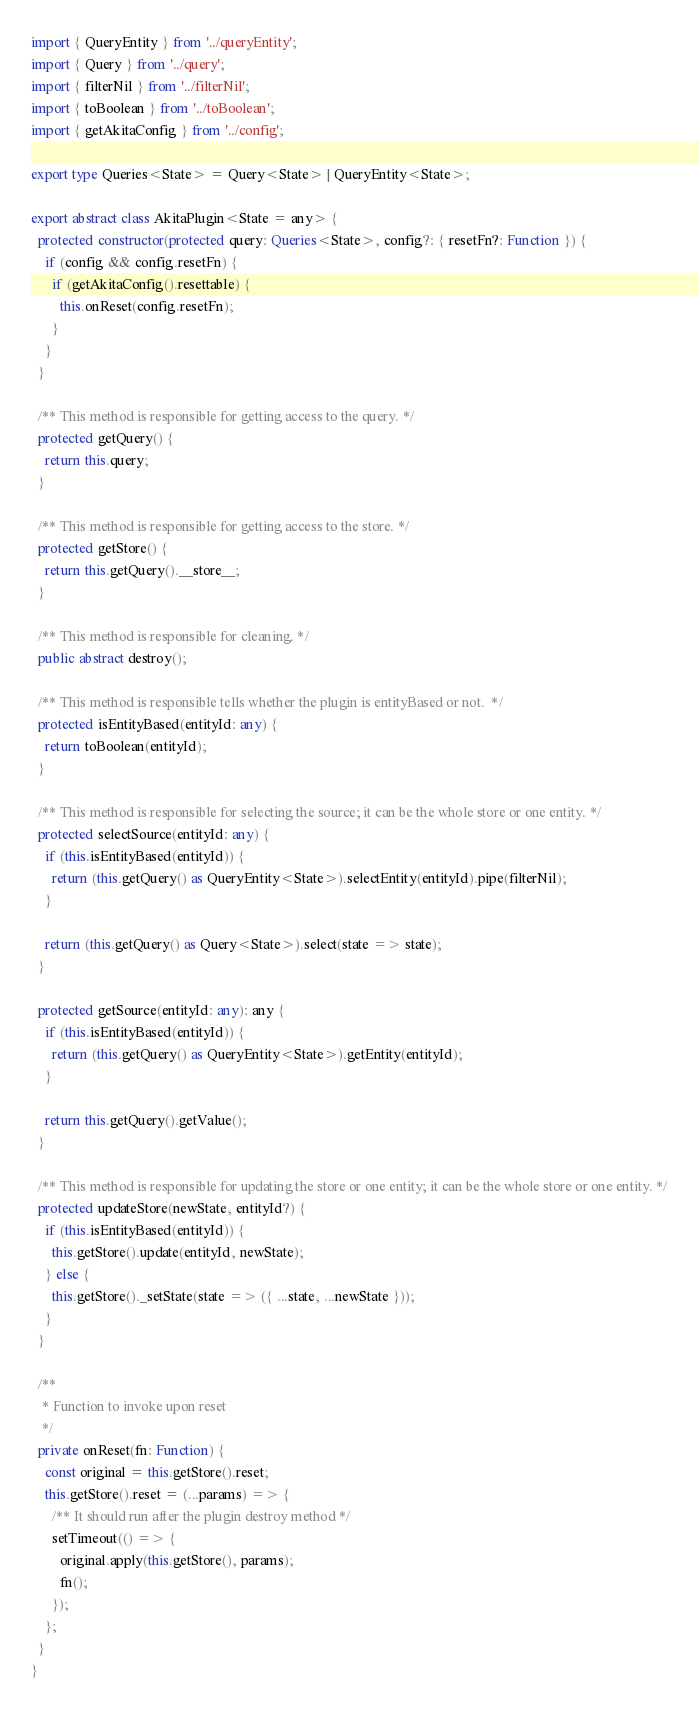<code> <loc_0><loc_0><loc_500><loc_500><_TypeScript_>import { QueryEntity } from '../queryEntity';
import { Query } from '../query';
import { filterNil } from '../filterNil';
import { toBoolean } from '../toBoolean';
import { getAkitaConfig } from '../config';

export type Queries<State> = Query<State> | QueryEntity<State>;

export abstract class AkitaPlugin<State = any> {
  protected constructor(protected query: Queries<State>, config?: { resetFn?: Function }) {
    if (config && config.resetFn) {
      if (getAkitaConfig().resettable) {
        this.onReset(config.resetFn);
      }
    }
  }

  /** This method is responsible for getting access to the query. */
  protected getQuery() {
    return this.query;
  }

  /** This method is responsible for getting access to the store. */
  protected getStore() {
    return this.getQuery().__store__;
  }

  /** This method is responsible for cleaning. */
  public abstract destroy();

  /** This method is responsible tells whether the plugin is entityBased or not.  */
  protected isEntityBased(entityId: any) {
    return toBoolean(entityId);
  }

  /** This method is responsible for selecting the source; it can be the whole store or one entity. */
  protected selectSource(entityId: any) {
    if (this.isEntityBased(entityId)) {
      return (this.getQuery() as QueryEntity<State>).selectEntity(entityId).pipe(filterNil);
    }

    return (this.getQuery() as Query<State>).select(state => state);
  }

  protected getSource(entityId: any): any {
    if (this.isEntityBased(entityId)) {
      return (this.getQuery() as QueryEntity<State>).getEntity(entityId);
    }

    return this.getQuery().getValue();
  }

  /** This method is responsible for updating the store or one entity; it can be the whole store or one entity. */
  protected updateStore(newState, entityId?) {
    if (this.isEntityBased(entityId)) {
      this.getStore().update(entityId, newState);
    } else {
      this.getStore()._setState(state => ({ ...state, ...newState }));
    }
  }

  /**
   * Function to invoke upon reset
   */
  private onReset(fn: Function) {
    const original = this.getStore().reset;
    this.getStore().reset = (...params) => {
      /** It should run after the plugin destroy method */
      setTimeout(() => {
        original.apply(this.getStore(), params);
        fn();
      });
    };
  }
}
</code> 